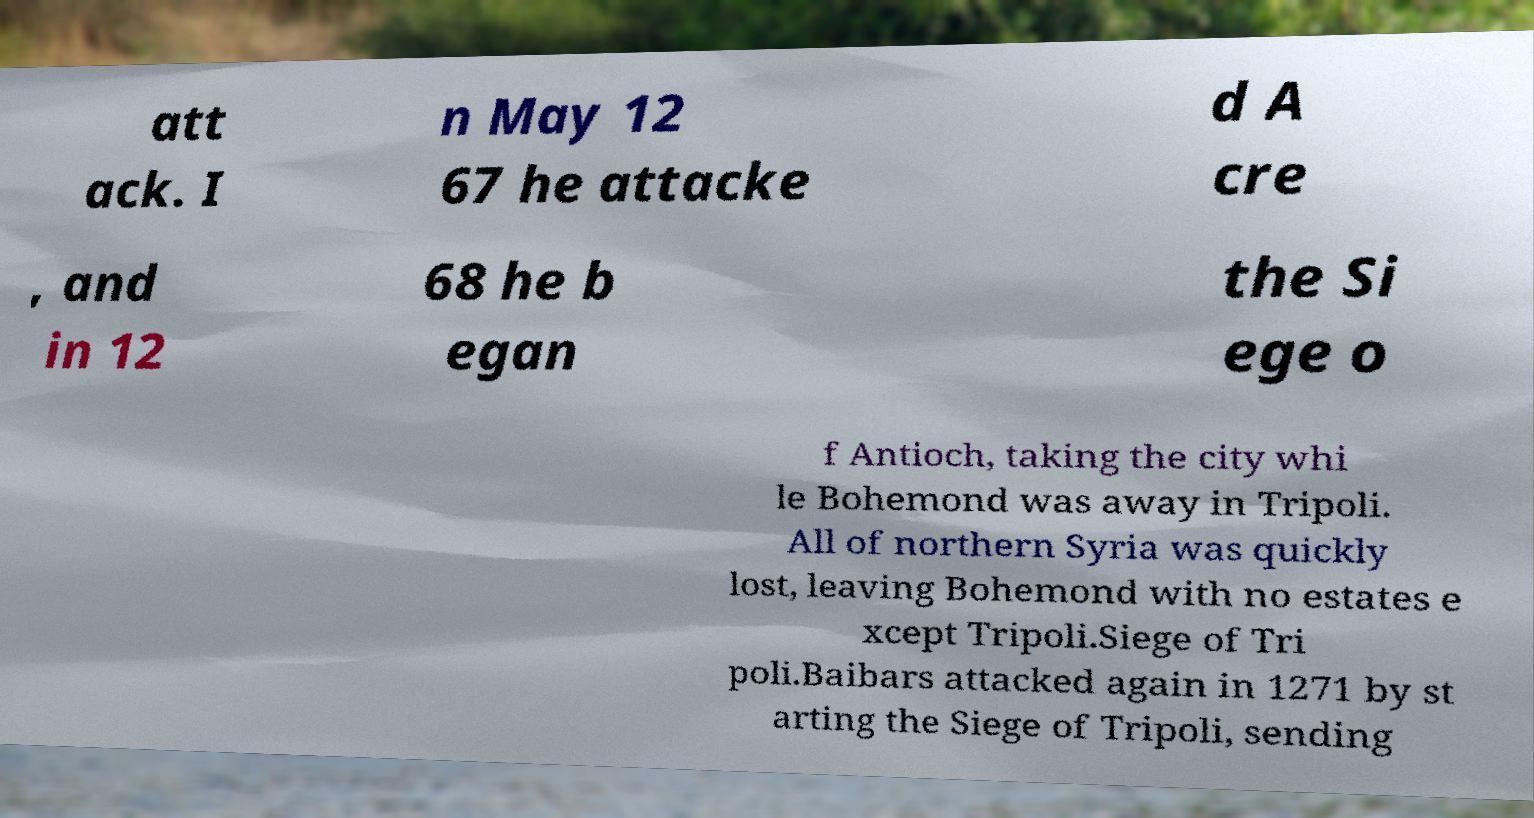Can you accurately transcribe the text from the provided image for me? att ack. I n May 12 67 he attacke d A cre , and in 12 68 he b egan the Si ege o f Antioch, taking the city whi le Bohemond was away in Tripoli. All of northern Syria was quickly lost, leaving Bohemond with no estates e xcept Tripoli.Siege of Tri poli.Baibars attacked again in 1271 by st arting the Siege of Tripoli, sending 